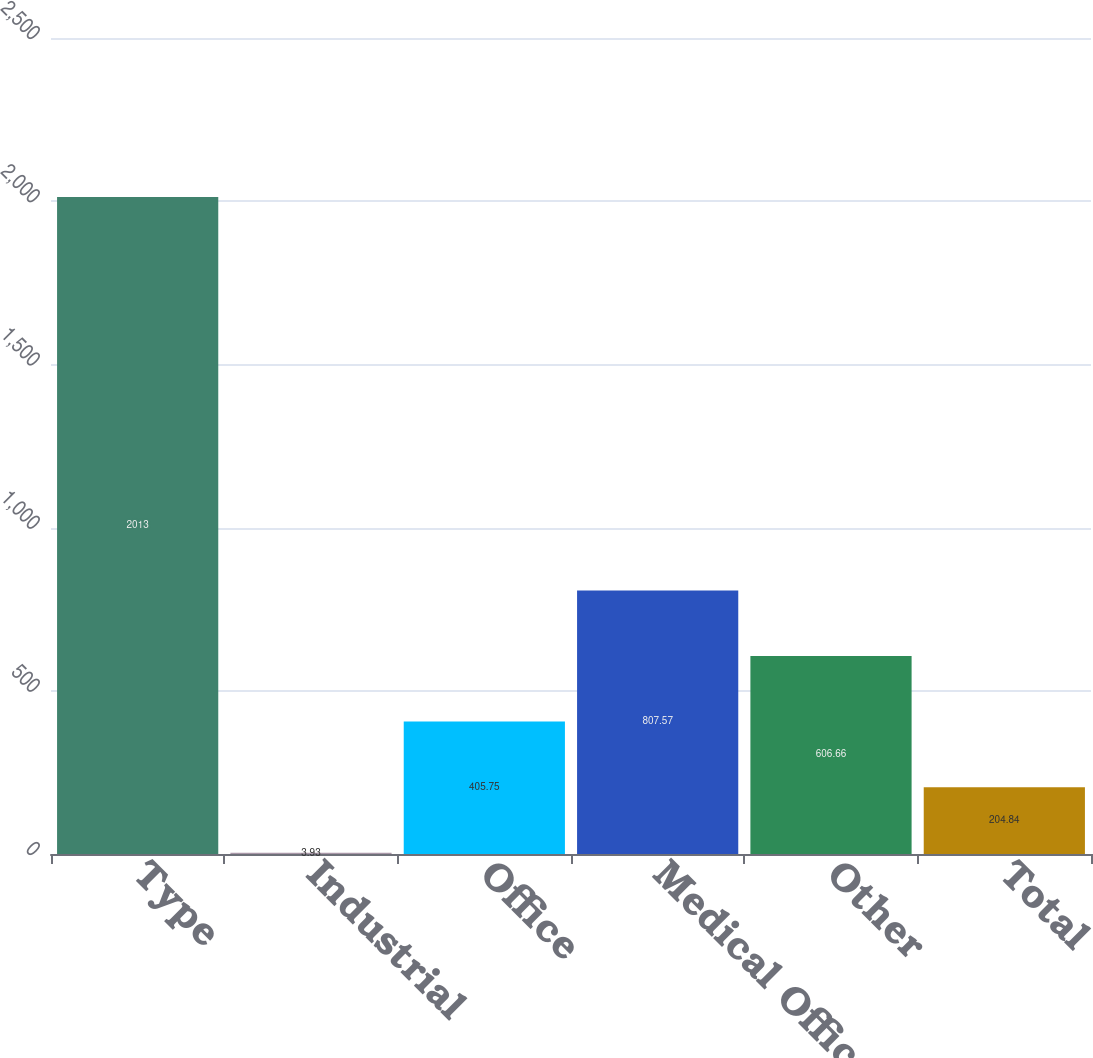<chart> <loc_0><loc_0><loc_500><loc_500><bar_chart><fcel>Type<fcel>Industrial<fcel>Office<fcel>Medical Office<fcel>Other<fcel>Total<nl><fcel>2013<fcel>3.93<fcel>405.75<fcel>807.57<fcel>606.66<fcel>204.84<nl></chart> 